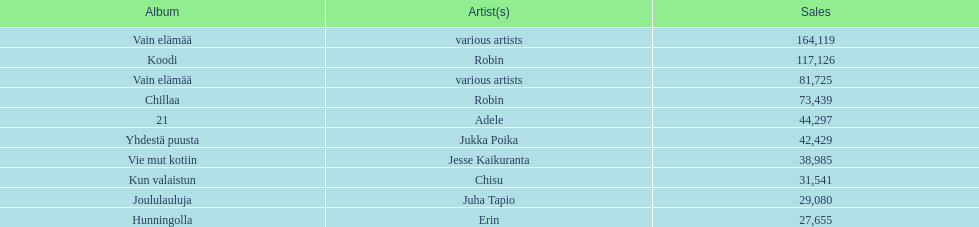Which was the last album to sell over 100,000 records? Koodi. 